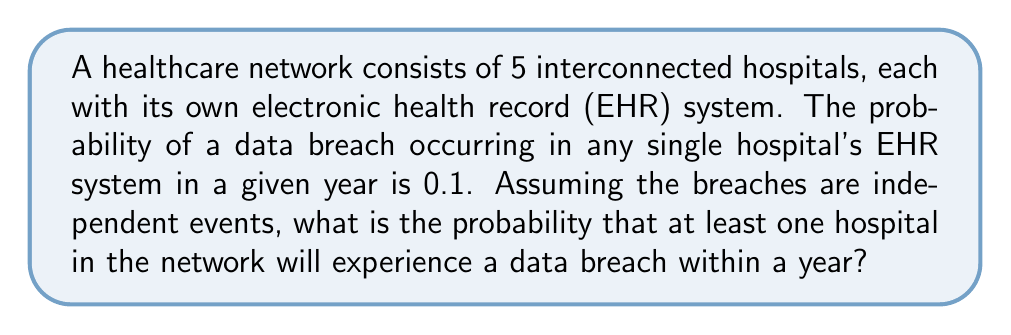Solve this math problem. Let's approach this step-by-step:

1) First, we need to find the probability that no breach occurs in a single hospital:
   $P(\text{no breach in one hospital}) = 1 - 0.1 = 0.9$

2) For the entire network to be secure, all 5 hospitals must avoid a breach. Since the events are independent, we multiply the individual probabilities:
   $P(\text{no breach in network}) = 0.9^5 = 0.59049$

3) The question asks for the probability of at least one breach, which is the complement of no breaches occurring:
   $P(\text{at least one breach}) = 1 - P(\text{no breach in network})$

4) Substituting the value we calculated:
   $P(\text{at least one breach}) = 1 - 0.59049 = 0.40951$

5) This can be expressed as a percentage:
   $0.40951 \times 100\% = 40.951\%$

Thus, there is approximately a 40.951% chance that at least one hospital in the network will experience a data breach within a year.
Answer: $40.951\%$ 